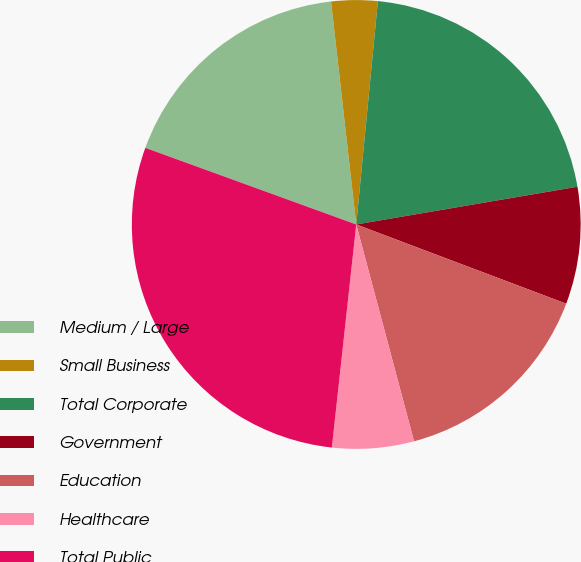Convert chart. <chart><loc_0><loc_0><loc_500><loc_500><pie_chart><fcel>Medium / Large<fcel>Small Business<fcel>Total Corporate<fcel>Government<fcel>Education<fcel>Healthcare<fcel>Total Public<nl><fcel>17.66%<fcel>3.33%<fcel>20.77%<fcel>8.43%<fcel>15.11%<fcel>5.88%<fcel>28.81%<nl></chart> 